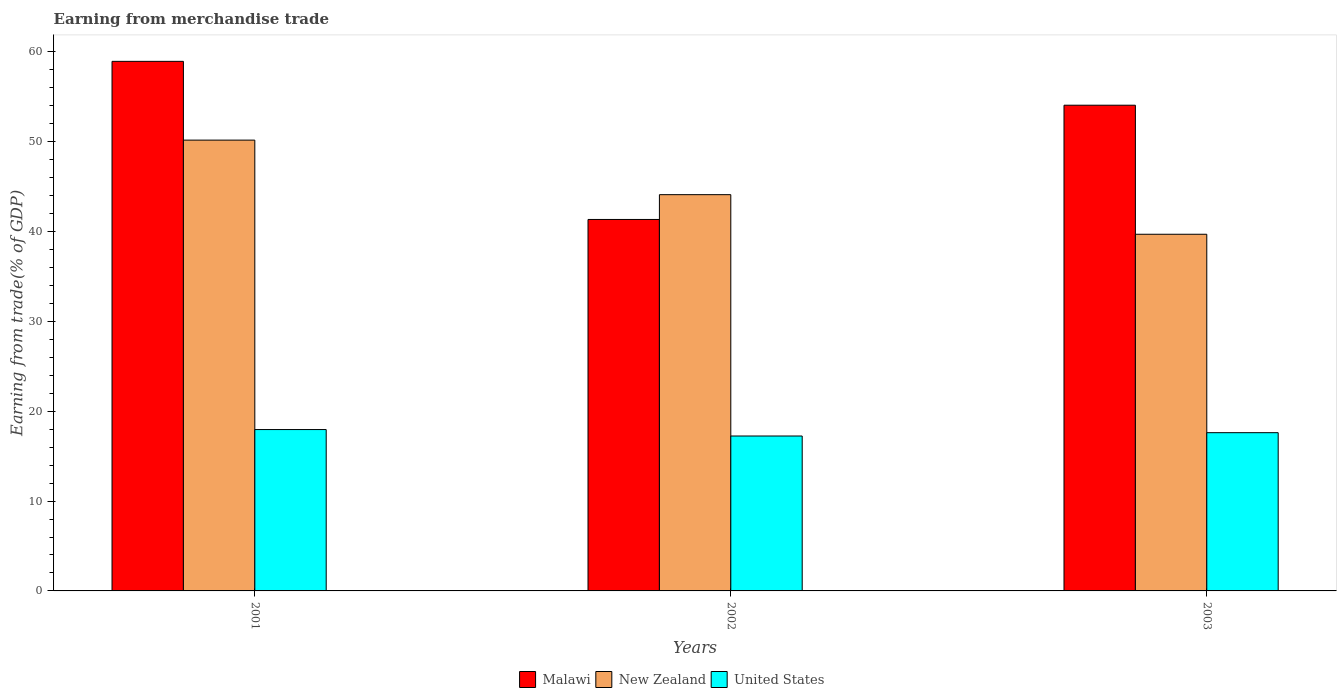How many groups of bars are there?
Offer a very short reply. 3. Are the number of bars per tick equal to the number of legend labels?
Your response must be concise. Yes. What is the label of the 2nd group of bars from the left?
Keep it short and to the point. 2002. What is the earnings from trade in United States in 2001?
Provide a short and direct response. 17.97. Across all years, what is the maximum earnings from trade in United States?
Keep it short and to the point. 17.97. Across all years, what is the minimum earnings from trade in New Zealand?
Give a very brief answer. 39.71. In which year was the earnings from trade in New Zealand maximum?
Your answer should be compact. 2001. In which year was the earnings from trade in New Zealand minimum?
Offer a very short reply. 2003. What is the total earnings from trade in New Zealand in the graph?
Your response must be concise. 134.01. What is the difference between the earnings from trade in Malawi in 2002 and that in 2003?
Provide a short and direct response. -12.72. What is the difference between the earnings from trade in Malawi in 2003 and the earnings from trade in United States in 2001?
Give a very brief answer. 36.11. What is the average earnings from trade in New Zealand per year?
Offer a terse response. 44.67. In the year 2001, what is the difference between the earnings from trade in Malawi and earnings from trade in United States?
Ensure brevity in your answer.  40.99. In how many years, is the earnings from trade in United States greater than 44 %?
Your answer should be compact. 0. What is the ratio of the earnings from trade in Malawi in 2001 to that in 2003?
Provide a succinct answer. 1.09. Is the earnings from trade in United States in 2001 less than that in 2003?
Provide a succinct answer. No. What is the difference between the highest and the second highest earnings from trade in United States?
Provide a succinct answer. 0.35. What is the difference between the highest and the lowest earnings from trade in Malawi?
Your answer should be compact. 17.6. What does the 3rd bar from the left in 2002 represents?
Keep it short and to the point. United States. What does the 3rd bar from the right in 2001 represents?
Your answer should be compact. Malawi. Is it the case that in every year, the sum of the earnings from trade in New Zealand and earnings from trade in United States is greater than the earnings from trade in Malawi?
Provide a succinct answer. Yes. How are the legend labels stacked?
Offer a very short reply. Horizontal. What is the title of the graph?
Your answer should be very brief. Earning from merchandise trade. Does "Bangladesh" appear as one of the legend labels in the graph?
Offer a terse response. No. What is the label or title of the X-axis?
Offer a very short reply. Years. What is the label or title of the Y-axis?
Your response must be concise. Earning from trade(% of GDP). What is the Earning from trade(% of GDP) of Malawi in 2001?
Your answer should be very brief. 58.96. What is the Earning from trade(% of GDP) of New Zealand in 2001?
Make the answer very short. 50.19. What is the Earning from trade(% of GDP) in United States in 2001?
Keep it short and to the point. 17.97. What is the Earning from trade(% of GDP) of Malawi in 2002?
Provide a short and direct response. 41.36. What is the Earning from trade(% of GDP) of New Zealand in 2002?
Your answer should be compact. 44.12. What is the Earning from trade(% of GDP) of United States in 2002?
Offer a very short reply. 17.25. What is the Earning from trade(% of GDP) of Malawi in 2003?
Give a very brief answer. 54.07. What is the Earning from trade(% of GDP) in New Zealand in 2003?
Offer a terse response. 39.71. What is the Earning from trade(% of GDP) in United States in 2003?
Offer a very short reply. 17.62. Across all years, what is the maximum Earning from trade(% of GDP) of Malawi?
Provide a short and direct response. 58.96. Across all years, what is the maximum Earning from trade(% of GDP) in New Zealand?
Offer a terse response. 50.19. Across all years, what is the maximum Earning from trade(% of GDP) in United States?
Provide a short and direct response. 17.97. Across all years, what is the minimum Earning from trade(% of GDP) of Malawi?
Offer a terse response. 41.36. Across all years, what is the minimum Earning from trade(% of GDP) in New Zealand?
Offer a terse response. 39.71. Across all years, what is the minimum Earning from trade(% of GDP) in United States?
Make the answer very short. 17.25. What is the total Earning from trade(% of GDP) in Malawi in the graph?
Keep it short and to the point. 154.39. What is the total Earning from trade(% of GDP) in New Zealand in the graph?
Provide a short and direct response. 134.01. What is the total Earning from trade(% of GDP) of United States in the graph?
Your answer should be very brief. 52.83. What is the difference between the Earning from trade(% of GDP) in Malawi in 2001 and that in 2002?
Ensure brevity in your answer.  17.6. What is the difference between the Earning from trade(% of GDP) in New Zealand in 2001 and that in 2002?
Make the answer very short. 6.07. What is the difference between the Earning from trade(% of GDP) of United States in 2001 and that in 2002?
Give a very brief answer. 0.72. What is the difference between the Earning from trade(% of GDP) in Malawi in 2001 and that in 2003?
Give a very brief answer. 4.88. What is the difference between the Earning from trade(% of GDP) of New Zealand in 2001 and that in 2003?
Your answer should be very brief. 10.48. What is the difference between the Earning from trade(% of GDP) of United States in 2001 and that in 2003?
Provide a succinct answer. 0.35. What is the difference between the Earning from trade(% of GDP) in Malawi in 2002 and that in 2003?
Provide a short and direct response. -12.72. What is the difference between the Earning from trade(% of GDP) of New Zealand in 2002 and that in 2003?
Your answer should be very brief. 4.41. What is the difference between the Earning from trade(% of GDP) of United States in 2002 and that in 2003?
Your answer should be compact. -0.37. What is the difference between the Earning from trade(% of GDP) in Malawi in 2001 and the Earning from trade(% of GDP) in New Zealand in 2002?
Your answer should be very brief. 14.84. What is the difference between the Earning from trade(% of GDP) of Malawi in 2001 and the Earning from trade(% of GDP) of United States in 2002?
Provide a short and direct response. 41.71. What is the difference between the Earning from trade(% of GDP) of New Zealand in 2001 and the Earning from trade(% of GDP) of United States in 2002?
Make the answer very short. 32.94. What is the difference between the Earning from trade(% of GDP) of Malawi in 2001 and the Earning from trade(% of GDP) of New Zealand in 2003?
Keep it short and to the point. 19.25. What is the difference between the Earning from trade(% of GDP) in Malawi in 2001 and the Earning from trade(% of GDP) in United States in 2003?
Keep it short and to the point. 41.34. What is the difference between the Earning from trade(% of GDP) in New Zealand in 2001 and the Earning from trade(% of GDP) in United States in 2003?
Your response must be concise. 32.57. What is the difference between the Earning from trade(% of GDP) of Malawi in 2002 and the Earning from trade(% of GDP) of New Zealand in 2003?
Your answer should be compact. 1.65. What is the difference between the Earning from trade(% of GDP) of Malawi in 2002 and the Earning from trade(% of GDP) of United States in 2003?
Your answer should be very brief. 23.74. What is the difference between the Earning from trade(% of GDP) of New Zealand in 2002 and the Earning from trade(% of GDP) of United States in 2003?
Provide a short and direct response. 26.5. What is the average Earning from trade(% of GDP) of Malawi per year?
Give a very brief answer. 51.46. What is the average Earning from trade(% of GDP) of New Zealand per year?
Your answer should be very brief. 44.67. What is the average Earning from trade(% of GDP) in United States per year?
Provide a succinct answer. 17.61. In the year 2001, what is the difference between the Earning from trade(% of GDP) of Malawi and Earning from trade(% of GDP) of New Zealand?
Offer a very short reply. 8.77. In the year 2001, what is the difference between the Earning from trade(% of GDP) in Malawi and Earning from trade(% of GDP) in United States?
Offer a terse response. 40.99. In the year 2001, what is the difference between the Earning from trade(% of GDP) of New Zealand and Earning from trade(% of GDP) of United States?
Make the answer very short. 32.22. In the year 2002, what is the difference between the Earning from trade(% of GDP) of Malawi and Earning from trade(% of GDP) of New Zealand?
Your response must be concise. -2.76. In the year 2002, what is the difference between the Earning from trade(% of GDP) in Malawi and Earning from trade(% of GDP) in United States?
Provide a succinct answer. 24.11. In the year 2002, what is the difference between the Earning from trade(% of GDP) in New Zealand and Earning from trade(% of GDP) in United States?
Your answer should be compact. 26.87. In the year 2003, what is the difference between the Earning from trade(% of GDP) in Malawi and Earning from trade(% of GDP) in New Zealand?
Ensure brevity in your answer.  14.37. In the year 2003, what is the difference between the Earning from trade(% of GDP) of Malawi and Earning from trade(% of GDP) of United States?
Make the answer very short. 36.46. In the year 2003, what is the difference between the Earning from trade(% of GDP) in New Zealand and Earning from trade(% of GDP) in United States?
Your answer should be very brief. 22.09. What is the ratio of the Earning from trade(% of GDP) in Malawi in 2001 to that in 2002?
Give a very brief answer. 1.43. What is the ratio of the Earning from trade(% of GDP) of New Zealand in 2001 to that in 2002?
Your response must be concise. 1.14. What is the ratio of the Earning from trade(% of GDP) of United States in 2001 to that in 2002?
Make the answer very short. 1.04. What is the ratio of the Earning from trade(% of GDP) in Malawi in 2001 to that in 2003?
Give a very brief answer. 1.09. What is the ratio of the Earning from trade(% of GDP) of New Zealand in 2001 to that in 2003?
Offer a terse response. 1.26. What is the ratio of the Earning from trade(% of GDP) of United States in 2001 to that in 2003?
Offer a terse response. 1.02. What is the ratio of the Earning from trade(% of GDP) of Malawi in 2002 to that in 2003?
Your answer should be compact. 0.76. What is the ratio of the Earning from trade(% of GDP) in New Zealand in 2002 to that in 2003?
Your answer should be very brief. 1.11. What is the difference between the highest and the second highest Earning from trade(% of GDP) in Malawi?
Offer a very short reply. 4.88. What is the difference between the highest and the second highest Earning from trade(% of GDP) in New Zealand?
Keep it short and to the point. 6.07. What is the difference between the highest and the second highest Earning from trade(% of GDP) of United States?
Make the answer very short. 0.35. What is the difference between the highest and the lowest Earning from trade(% of GDP) in Malawi?
Your answer should be very brief. 17.6. What is the difference between the highest and the lowest Earning from trade(% of GDP) of New Zealand?
Ensure brevity in your answer.  10.48. What is the difference between the highest and the lowest Earning from trade(% of GDP) of United States?
Offer a terse response. 0.72. 